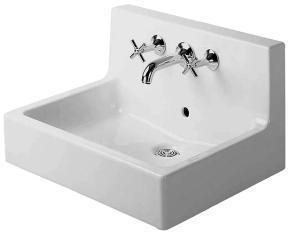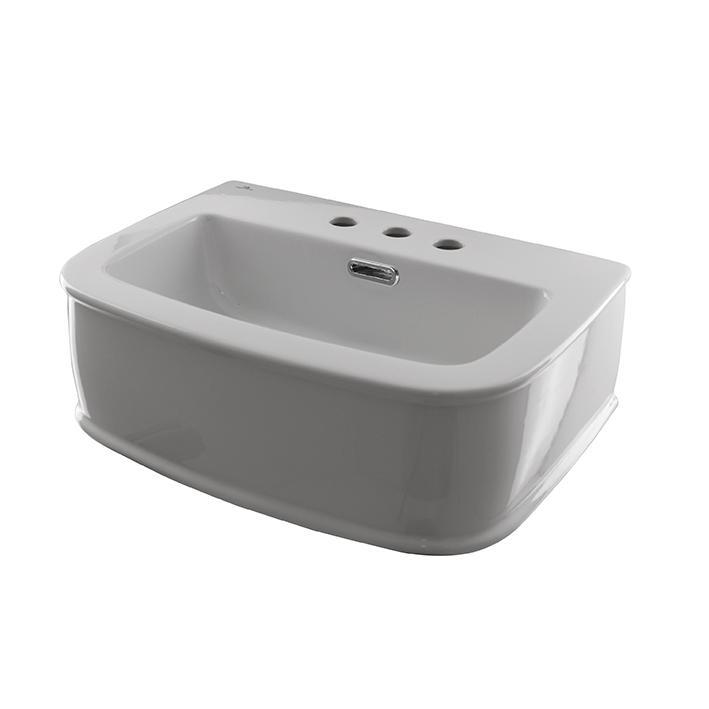The first image is the image on the left, the second image is the image on the right. Assess this claim about the two images: "IN at least one image there is a square white water basin on top of a dark wooden shelve.". Correct or not? Answer yes or no. No. The first image is the image on the left, the second image is the image on the right. Analyze the images presented: Is the assertion "There are three faucets." valid? Answer yes or no. No. 